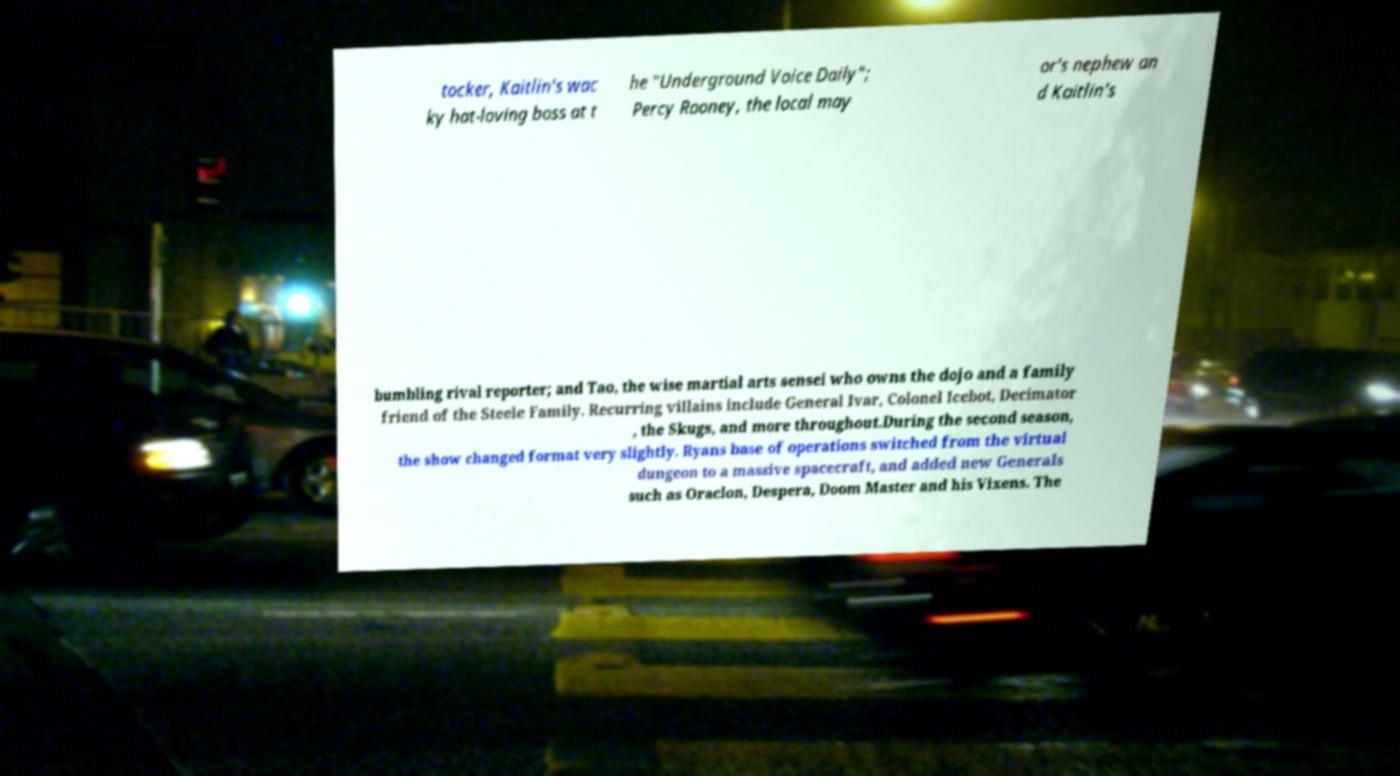What messages or text are displayed in this image? I need them in a readable, typed format. tocker, Kaitlin's wac ky hat-loving boss at t he "Underground Voice Daily"; Percy Rooney, the local may or's nephew an d Kaitlin's bumbling rival reporter; and Tao, the wise martial arts sensei who owns the dojo and a family friend of the Steele Family. Recurring villains include General Ivar, Colonel Icebot, Decimator , the Skugs, and more throughout.During the second season, the show changed format very slightly. Ryans base of operations switched from the virtual dungeon to a massive spacecraft, and added new Generals such as Oraclon, Despera, Doom Master and his Vixens. The 